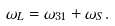<formula> <loc_0><loc_0><loc_500><loc_500>\omega _ { L } = \omega _ { 3 1 } + \omega _ { S } .</formula> 